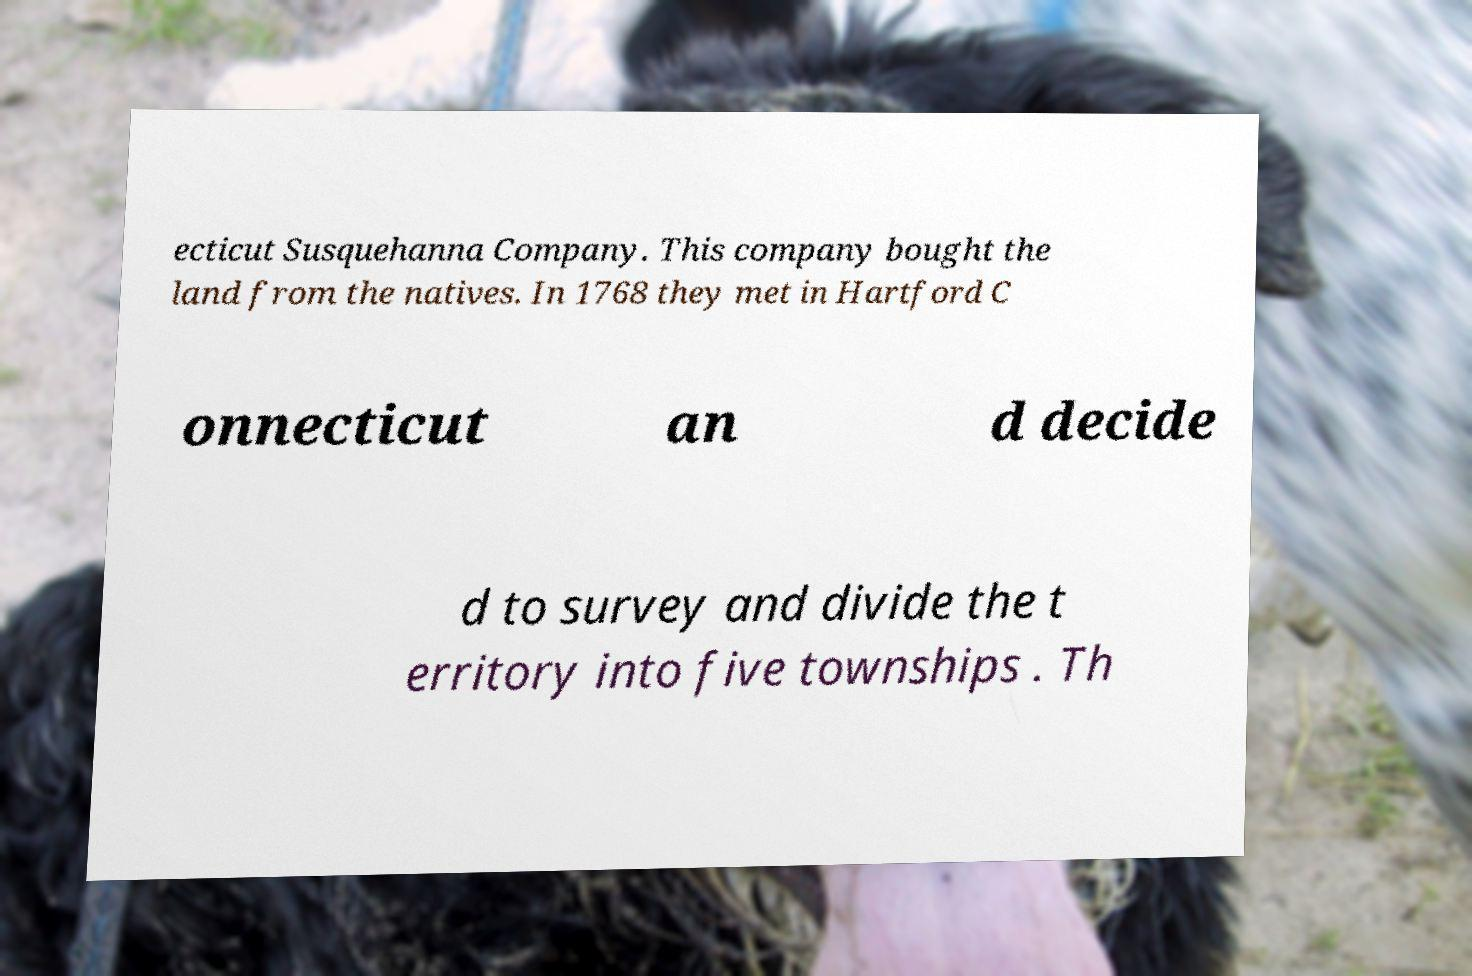There's text embedded in this image that I need extracted. Can you transcribe it verbatim? ecticut Susquehanna Company. This company bought the land from the natives. In 1768 they met in Hartford C onnecticut an d decide d to survey and divide the t erritory into five townships . Th 